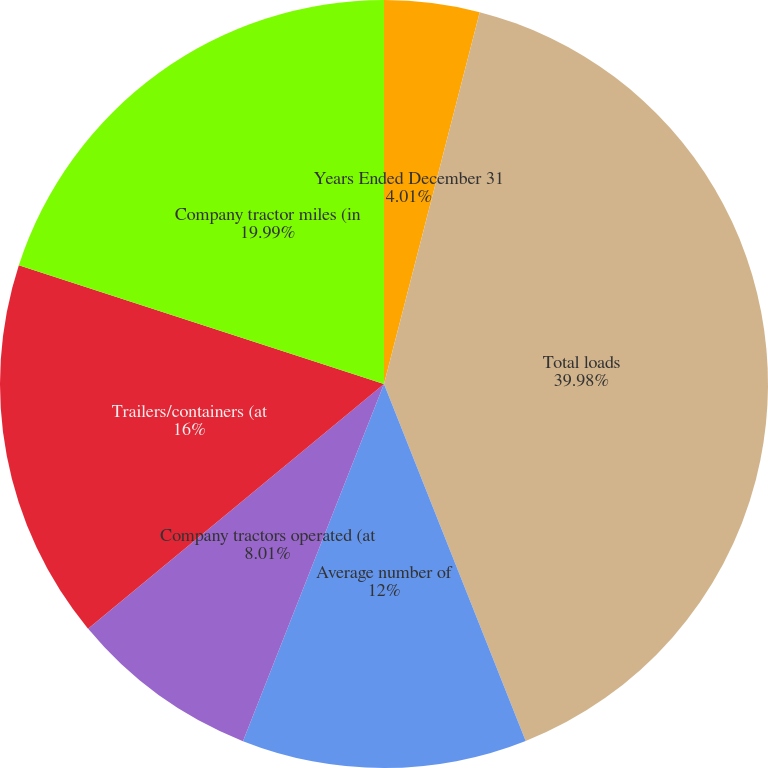Convert chart. <chart><loc_0><loc_0><loc_500><loc_500><pie_chart><fcel>Years Ended December 31<fcel>Total loads<fcel>Average number of<fcel>Company tractors operated (at<fcel>Independent contractors (at<fcel>Trailers/containers (at<fcel>Company tractor miles (in<nl><fcel>4.01%<fcel>39.97%<fcel>12.0%<fcel>8.01%<fcel>0.01%<fcel>16.0%<fcel>19.99%<nl></chart> 